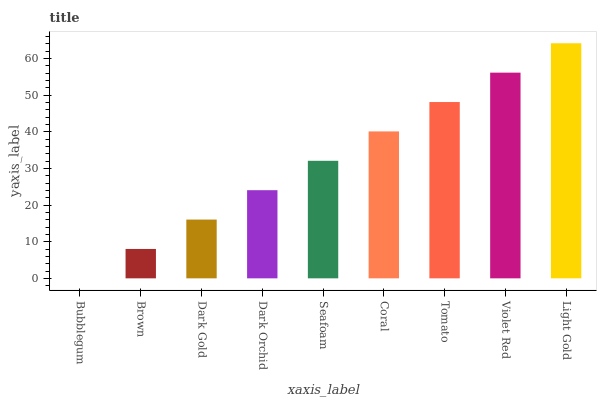Is Bubblegum the minimum?
Answer yes or no. Yes. Is Light Gold the maximum?
Answer yes or no. Yes. Is Brown the minimum?
Answer yes or no. No. Is Brown the maximum?
Answer yes or no. No. Is Brown greater than Bubblegum?
Answer yes or no. Yes. Is Bubblegum less than Brown?
Answer yes or no. Yes. Is Bubblegum greater than Brown?
Answer yes or no. No. Is Brown less than Bubblegum?
Answer yes or no. No. Is Seafoam the high median?
Answer yes or no. Yes. Is Seafoam the low median?
Answer yes or no. Yes. Is Light Gold the high median?
Answer yes or no. No. Is Light Gold the low median?
Answer yes or no. No. 